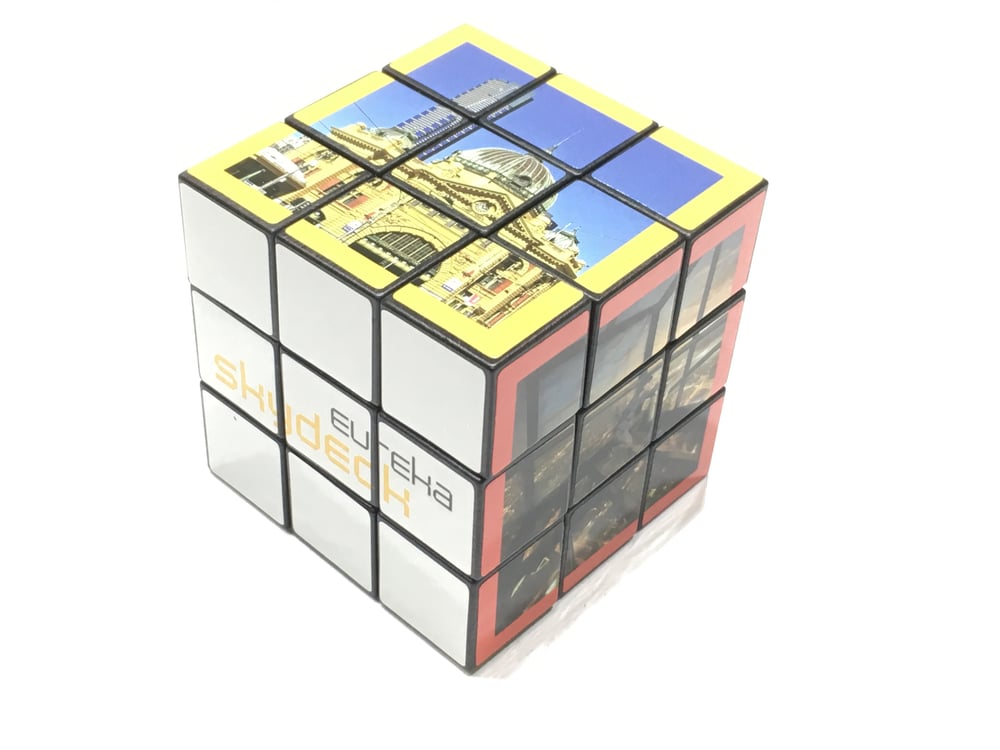What do the different colors and segments on this cube represent in the context of the landmark? The different colors and segments on the cube likely correspond to different parts or features of the landmark. Each side of the cube could represent a unique view or section, highlighting various architectural elements like the dome, facades, and intricate window designs. The yellow and red areas might be used to enhance visibility and distinction of each section. How do the clues on this cube provide insights into the history and significance of the landmark? The architectural elements visible on the cube, such as the dome and classical arches, provide insights into the landmark's historical and cultural significance. Such structures are often associated with important government, religious, or cultural institutions. The design details, like the ornate decorations and large windows, suggest a building of historical importance, reflecting a period when such grand architecture was prevalent. Additionally, any text or partial words seen on the cube, such as 'SHINDECH', could provide further hints about the landmark's identity and significance. 